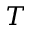Convert formula to latex. <formula><loc_0><loc_0><loc_500><loc_500>T</formula> 